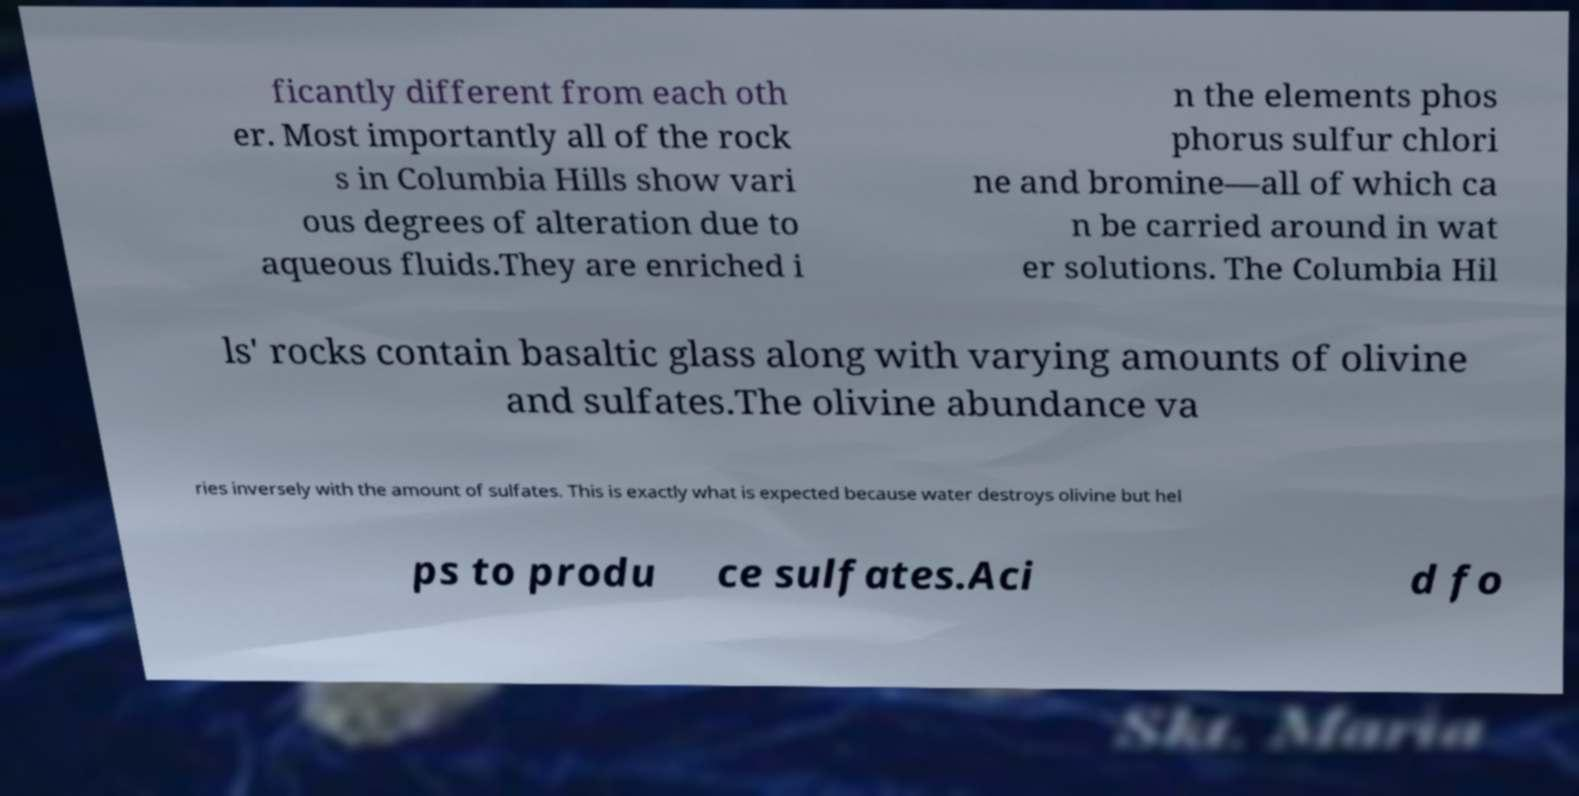Can you accurately transcribe the text from the provided image for me? ficantly different from each oth er. Most importantly all of the rock s in Columbia Hills show vari ous degrees of alteration due to aqueous fluids.They are enriched i n the elements phos phorus sulfur chlori ne and bromine—all of which ca n be carried around in wat er solutions. The Columbia Hil ls' rocks contain basaltic glass along with varying amounts of olivine and sulfates.The olivine abundance va ries inversely with the amount of sulfates. This is exactly what is expected because water destroys olivine but hel ps to produ ce sulfates.Aci d fo 